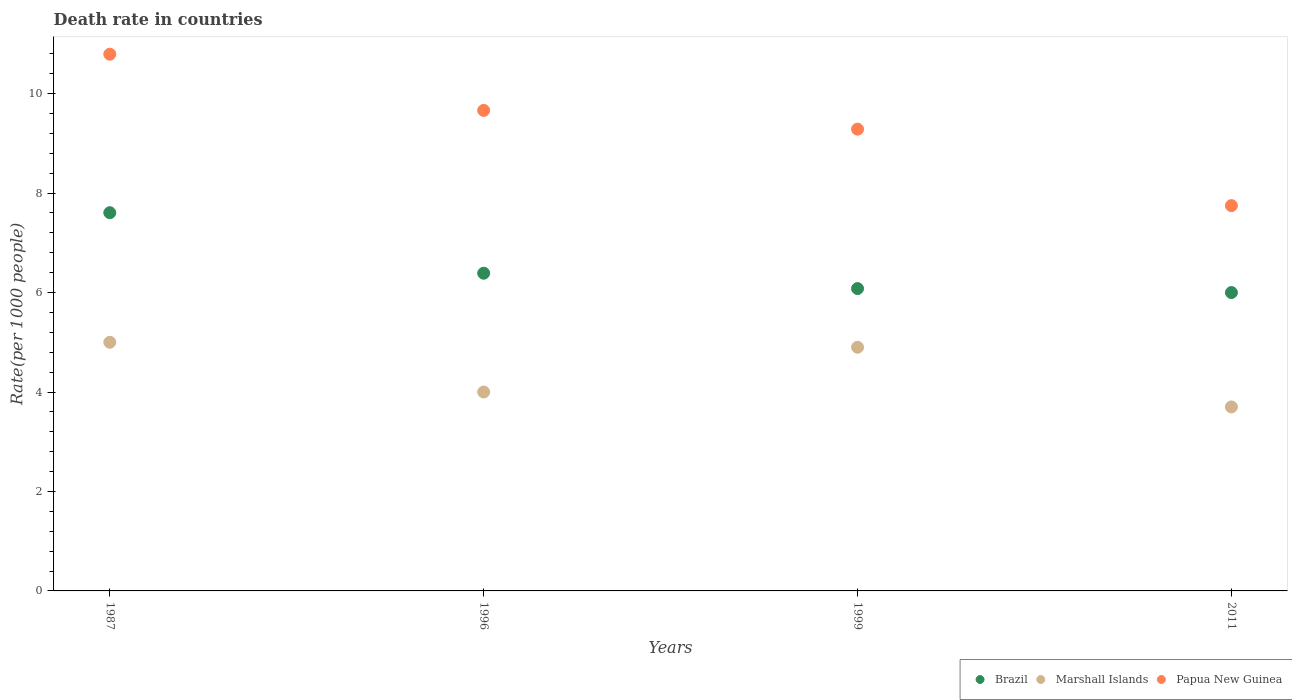Is the number of dotlines equal to the number of legend labels?
Provide a short and direct response. Yes. Across all years, what is the maximum death rate in Brazil?
Your response must be concise. 7.61. What is the total death rate in Papua New Guinea in the graph?
Provide a succinct answer. 37.49. What is the difference between the death rate in Brazil in 1996 and that in 1999?
Ensure brevity in your answer.  0.31. What is the difference between the death rate in Marshall Islands in 1999 and the death rate in Papua New Guinea in 1996?
Make the answer very short. -4.76. In the year 1996, what is the difference between the death rate in Marshall Islands and death rate in Papua New Guinea?
Give a very brief answer. -5.66. What is the ratio of the death rate in Brazil in 1996 to that in 2011?
Give a very brief answer. 1.06. Is the death rate in Brazil in 1996 less than that in 2011?
Make the answer very short. No. What is the difference between the highest and the second highest death rate in Brazil?
Give a very brief answer. 1.22. What is the difference between the highest and the lowest death rate in Papua New Guinea?
Your response must be concise. 3.05. Is the sum of the death rate in Brazil in 1987 and 1999 greater than the maximum death rate in Marshall Islands across all years?
Ensure brevity in your answer.  Yes. Does the death rate in Marshall Islands monotonically increase over the years?
Your answer should be compact. No. Is the death rate in Brazil strictly less than the death rate in Papua New Guinea over the years?
Your answer should be very brief. Yes. How many dotlines are there?
Provide a short and direct response. 3. How many years are there in the graph?
Keep it short and to the point. 4. What is the difference between two consecutive major ticks on the Y-axis?
Keep it short and to the point. 2. How many legend labels are there?
Your answer should be very brief. 3. What is the title of the graph?
Your answer should be very brief. Death rate in countries. What is the label or title of the Y-axis?
Your response must be concise. Rate(per 1000 people). What is the Rate(per 1000 people) in Brazil in 1987?
Offer a terse response. 7.61. What is the Rate(per 1000 people) of Marshall Islands in 1987?
Make the answer very short. 5. What is the Rate(per 1000 people) of Papua New Guinea in 1987?
Keep it short and to the point. 10.79. What is the Rate(per 1000 people) of Brazil in 1996?
Keep it short and to the point. 6.39. What is the Rate(per 1000 people) of Marshall Islands in 1996?
Your response must be concise. 4. What is the Rate(per 1000 people) in Papua New Guinea in 1996?
Keep it short and to the point. 9.66. What is the Rate(per 1000 people) of Brazil in 1999?
Provide a short and direct response. 6.08. What is the Rate(per 1000 people) in Marshall Islands in 1999?
Make the answer very short. 4.9. What is the Rate(per 1000 people) of Papua New Guinea in 1999?
Make the answer very short. 9.29. What is the Rate(per 1000 people) in Papua New Guinea in 2011?
Offer a terse response. 7.75. Across all years, what is the maximum Rate(per 1000 people) in Brazil?
Offer a terse response. 7.61. Across all years, what is the maximum Rate(per 1000 people) of Marshall Islands?
Ensure brevity in your answer.  5. Across all years, what is the maximum Rate(per 1000 people) in Papua New Guinea?
Offer a terse response. 10.79. Across all years, what is the minimum Rate(per 1000 people) in Papua New Guinea?
Your response must be concise. 7.75. What is the total Rate(per 1000 people) in Brazil in the graph?
Keep it short and to the point. 26.07. What is the total Rate(per 1000 people) in Marshall Islands in the graph?
Provide a succinct answer. 17.6. What is the total Rate(per 1000 people) in Papua New Guinea in the graph?
Your answer should be very brief. 37.49. What is the difference between the Rate(per 1000 people) of Brazil in 1987 and that in 1996?
Offer a terse response. 1.22. What is the difference between the Rate(per 1000 people) of Papua New Guinea in 1987 and that in 1996?
Provide a short and direct response. 1.13. What is the difference between the Rate(per 1000 people) of Brazil in 1987 and that in 1999?
Make the answer very short. 1.53. What is the difference between the Rate(per 1000 people) of Marshall Islands in 1987 and that in 1999?
Keep it short and to the point. 0.1. What is the difference between the Rate(per 1000 people) in Papua New Guinea in 1987 and that in 1999?
Make the answer very short. 1.51. What is the difference between the Rate(per 1000 people) in Brazil in 1987 and that in 2011?
Your answer should be very brief. 1.61. What is the difference between the Rate(per 1000 people) in Papua New Guinea in 1987 and that in 2011?
Make the answer very short. 3.04. What is the difference between the Rate(per 1000 people) of Brazil in 1996 and that in 1999?
Keep it short and to the point. 0.31. What is the difference between the Rate(per 1000 people) of Marshall Islands in 1996 and that in 1999?
Make the answer very short. -0.9. What is the difference between the Rate(per 1000 people) of Papua New Guinea in 1996 and that in 1999?
Keep it short and to the point. 0.38. What is the difference between the Rate(per 1000 people) in Brazil in 1996 and that in 2011?
Your answer should be compact. 0.39. What is the difference between the Rate(per 1000 people) of Marshall Islands in 1996 and that in 2011?
Make the answer very short. 0.3. What is the difference between the Rate(per 1000 people) of Papua New Guinea in 1996 and that in 2011?
Your response must be concise. 1.92. What is the difference between the Rate(per 1000 people) in Marshall Islands in 1999 and that in 2011?
Offer a terse response. 1.2. What is the difference between the Rate(per 1000 people) of Papua New Guinea in 1999 and that in 2011?
Provide a succinct answer. 1.54. What is the difference between the Rate(per 1000 people) of Brazil in 1987 and the Rate(per 1000 people) of Marshall Islands in 1996?
Provide a short and direct response. 3.61. What is the difference between the Rate(per 1000 people) in Brazil in 1987 and the Rate(per 1000 people) in Papua New Guinea in 1996?
Ensure brevity in your answer.  -2.06. What is the difference between the Rate(per 1000 people) of Marshall Islands in 1987 and the Rate(per 1000 people) of Papua New Guinea in 1996?
Your answer should be very brief. -4.66. What is the difference between the Rate(per 1000 people) in Brazil in 1987 and the Rate(per 1000 people) in Marshall Islands in 1999?
Make the answer very short. 2.71. What is the difference between the Rate(per 1000 people) in Brazil in 1987 and the Rate(per 1000 people) in Papua New Guinea in 1999?
Keep it short and to the point. -1.68. What is the difference between the Rate(per 1000 people) in Marshall Islands in 1987 and the Rate(per 1000 people) in Papua New Guinea in 1999?
Keep it short and to the point. -4.29. What is the difference between the Rate(per 1000 people) in Brazil in 1987 and the Rate(per 1000 people) in Marshall Islands in 2011?
Your response must be concise. 3.91. What is the difference between the Rate(per 1000 people) in Brazil in 1987 and the Rate(per 1000 people) in Papua New Guinea in 2011?
Make the answer very short. -0.14. What is the difference between the Rate(per 1000 people) in Marshall Islands in 1987 and the Rate(per 1000 people) in Papua New Guinea in 2011?
Keep it short and to the point. -2.75. What is the difference between the Rate(per 1000 people) in Brazil in 1996 and the Rate(per 1000 people) in Marshall Islands in 1999?
Offer a very short reply. 1.49. What is the difference between the Rate(per 1000 people) of Brazil in 1996 and the Rate(per 1000 people) of Papua New Guinea in 1999?
Your answer should be compact. -2.9. What is the difference between the Rate(per 1000 people) in Marshall Islands in 1996 and the Rate(per 1000 people) in Papua New Guinea in 1999?
Offer a very short reply. -5.29. What is the difference between the Rate(per 1000 people) of Brazil in 1996 and the Rate(per 1000 people) of Marshall Islands in 2011?
Provide a short and direct response. 2.69. What is the difference between the Rate(per 1000 people) of Brazil in 1996 and the Rate(per 1000 people) of Papua New Guinea in 2011?
Ensure brevity in your answer.  -1.36. What is the difference between the Rate(per 1000 people) of Marshall Islands in 1996 and the Rate(per 1000 people) of Papua New Guinea in 2011?
Ensure brevity in your answer.  -3.75. What is the difference between the Rate(per 1000 people) in Brazil in 1999 and the Rate(per 1000 people) in Marshall Islands in 2011?
Make the answer very short. 2.38. What is the difference between the Rate(per 1000 people) of Brazil in 1999 and the Rate(per 1000 people) of Papua New Guinea in 2011?
Offer a very short reply. -1.67. What is the difference between the Rate(per 1000 people) in Marshall Islands in 1999 and the Rate(per 1000 people) in Papua New Guinea in 2011?
Give a very brief answer. -2.85. What is the average Rate(per 1000 people) of Brazil per year?
Ensure brevity in your answer.  6.52. What is the average Rate(per 1000 people) in Marshall Islands per year?
Your answer should be compact. 4.4. What is the average Rate(per 1000 people) in Papua New Guinea per year?
Offer a terse response. 9.37. In the year 1987, what is the difference between the Rate(per 1000 people) of Brazil and Rate(per 1000 people) of Marshall Islands?
Your answer should be very brief. 2.61. In the year 1987, what is the difference between the Rate(per 1000 people) of Brazil and Rate(per 1000 people) of Papua New Guinea?
Ensure brevity in your answer.  -3.19. In the year 1987, what is the difference between the Rate(per 1000 people) in Marshall Islands and Rate(per 1000 people) in Papua New Guinea?
Offer a very short reply. -5.79. In the year 1996, what is the difference between the Rate(per 1000 people) in Brazil and Rate(per 1000 people) in Marshall Islands?
Offer a terse response. 2.39. In the year 1996, what is the difference between the Rate(per 1000 people) of Brazil and Rate(per 1000 people) of Papua New Guinea?
Keep it short and to the point. -3.27. In the year 1996, what is the difference between the Rate(per 1000 people) of Marshall Islands and Rate(per 1000 people) of Papua New Guinea?
Offer a terse response. -5.66. In the year 1999, what is the difference between the Rate(per 1000 people) of Brazil and Rate(per 1000 people) of Marshall Islands?
Keep it short and to the point. 1.18. In the year 1999, what is the difference between the Rate(per 1000 people) in Brazil and Rate(per 1000 people) in Papua New Guinea?
Your answer should be very brief. -3.21. In the year 1999, what is the difference between the Rate(per 1000 people) of Marshall Islands and Rate(per 1000 people) of Papua New Guinea?
Offer a terse response. -4.39. In the year 2011, what is the difference between the Rate(per 1000 people) of Brazil and Rate(per 1000 people) of Marshall Islands?
Give a very brief answer. 2.3. In the year 2011, what is the difference between the Rate(per 1000 people) of Brazil and Rate(per 1000 people) of Papua New Guinea?
Your response must be concise. -1.75. In the year 2011, what is the difference between the Rate(per 1000 people) of Marshall Islands and Rate(per 1000 people) of Papua New Guinea?
Provide a short and direct response. -4.05. What is the ratio of the Rate(per 1000 people) of Brazil in 1987 to that in 1996?
Ensure brevity in your answer.  1.19. What is the ratio of the Rate(per 1000 people) of Marshall Islands in 1987 to that in 1996?
Give a very brief answer. 1.25. What is the ratio of the Rate(per 1000 people) of Papua New Guinea in 1987 to that in 1996?
Ensure brevity in your answer.  1.12. What is the ratio of the Rate(per 1000 people) of Brazil in 1987 to that in 1999?
Your answer should be very brief. 1.25. What is the ratio of the Rate(per 1000 people) in Marshall Islands in 1987 to that in 1999?
Offer a very short reply. 1.02. What is the ratio of the Rate(per 1000 people) in Papua New Guinea in 1987 to that in 1999?
Give a very brief answer. 1.16. What is the ratio of the Rate(per 1000 people) in Brazil in 1987 to that in 2011?
Offer a terse response. 1.27. What is the ratio of the Rate(per 1000 people) of Marshall Islands in 1987 to that in 2011?
Give a very brief answer. 1.35. What is the ratio of the Rate(per 1000 people) in Papua New Guinea in 1987 to that in 2011?
Make the answer very short. 1.39. What is the ratio of the Rate(per 1000 people) in Brazil in 1996 to that in 1999?
Your answer should be very brief. 1.05. What is the ratio of the Rate(per 1000 people) of Marshall Islands in 1996 to that in 1999?
Ensure brevity in your answer.  0.82. What is the ratio of the Rate(per 1000 people) of Papua New Guinea in 1996 to that in 1999?
Give a very brief answer. 1.04. What is the ratio of the Rate(per 1000 people) of Brazil in 1996 to that in 2011?
Keep it short and to the point. 1.06. What is the ratio of the Rate(per 1000 people) in Marshall Islands in 1996 to that in 2011?
Provide a succinct answer. 1.08. What is the ratio of the Rate(per 1000 people) in Papua New Guinea in 1996 to that in 2011?
Offer a terse response. 1.25. What is the ratio of the Rate(per 1000 people) in Brazil in 1999 to that in 2011?
Make the answer very short. 1.01. What is the ratio of the Rate(per 1000 people) of Marshall Islands in 1999 to that in 2011?
Provide a short and direct response. 1.32. What is the ratio of the Rate(per 1000 people) in Papua New Guinea in 1999 to that in 2011?
Make the answer very short. 1.2. What is the difference between the highest and the second highest Rate(per 1000 people) in Brazil?
Your answer should be compact. 1.22. What is the difference between the highest and the second highest Rate(per 1000 people) in Marshall Islands?
Keep it short and to the point. 0.1. What is the difference between the highest and the second highest Rate(per 1000 people) in Papua New Guinea?
Provide a succinct answer. 1.13. What is the difference between the highest and the lowest Rate(per 1000 people) of Brazil?
Offer a terse response. 1.61. What is the difference between the highest and the lowest Rate(per 1000 people) in Marshall Islands?
Keep it short and to the point. 1.3. What is the difference between the highest and the lowest Rate(per 1000 people) in Papua New Guinea?
Make the answer very short. 3.04. 